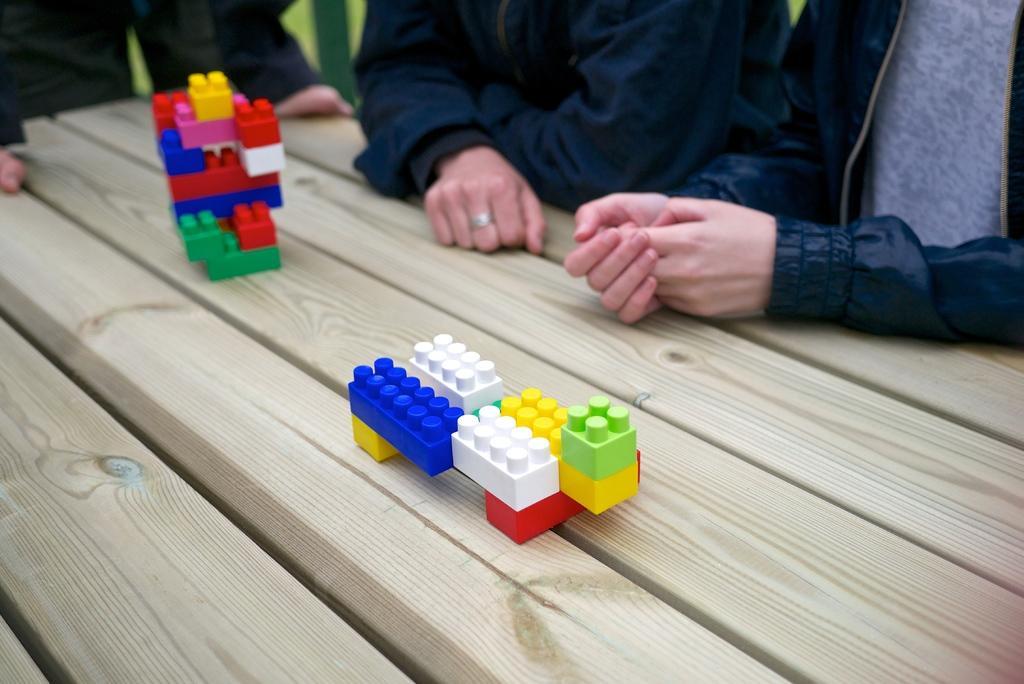Could you give a brief overview of what you see in this image? In this picture I can see building blocks on the table and I can see few people. 